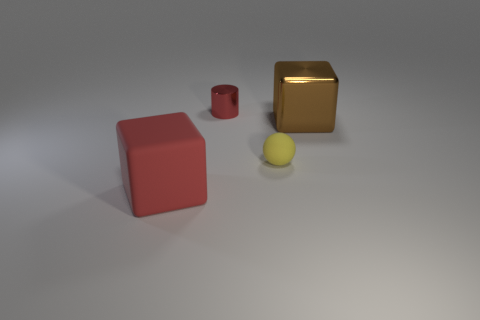Add 4 tiny things. How many objects exist? 8 Subtract all cylinders. How many objects are left? 3 Subtract all matte cubes. Subtract all big red cubes. How many objects are left? 2 Add 4 tiny matte things. How many tiny matte things are left? 5 Add 2 large cubes. How many large cubes exist? 4 Subtract 0 yellow cylinders. How many objects are left? 4 